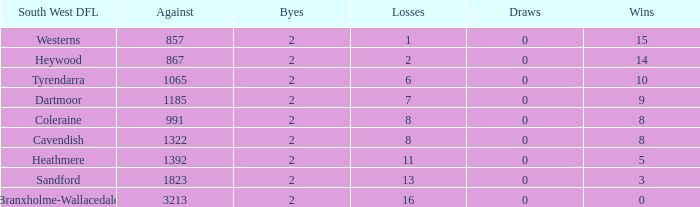In branxholme-wallacedale's south west dfl, which losses have less than 2 byes? None. Can you give me this table as a dict? {'header': ['South West DFL', 'Against', 'Byes', 'Losses', 'Draws', 'Wins'], 'rows': [['Westerns', '857', '2', '1', '0', '15'], ['Heywood', '867', '2', '2', '0', '14'], ['Tyrendarra', '1065', '2', '6', '0', '10'], ['Dartmoor', '1185', '2', '7', '0', '9'], ['Coleraine', '991', '2', '8', '0', '8'], ['Cavendish', '1322', '2', '8', '0', '8'], ['Heathmere', '1392', '2', '11', '0', '5'], ['Sandford', '1823', '2', '13', '0', '3'], ['Branxholme-Wallacedale', '3213', '2', '16', '0', '0']]} 